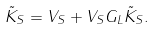<formula> <loc_0><loc_0><loc_500><loc_500>\tilde { K } _ { S } = V _ { S } + V _ { S } G _ { L } \tilde { K } _ { S } .</formula> 